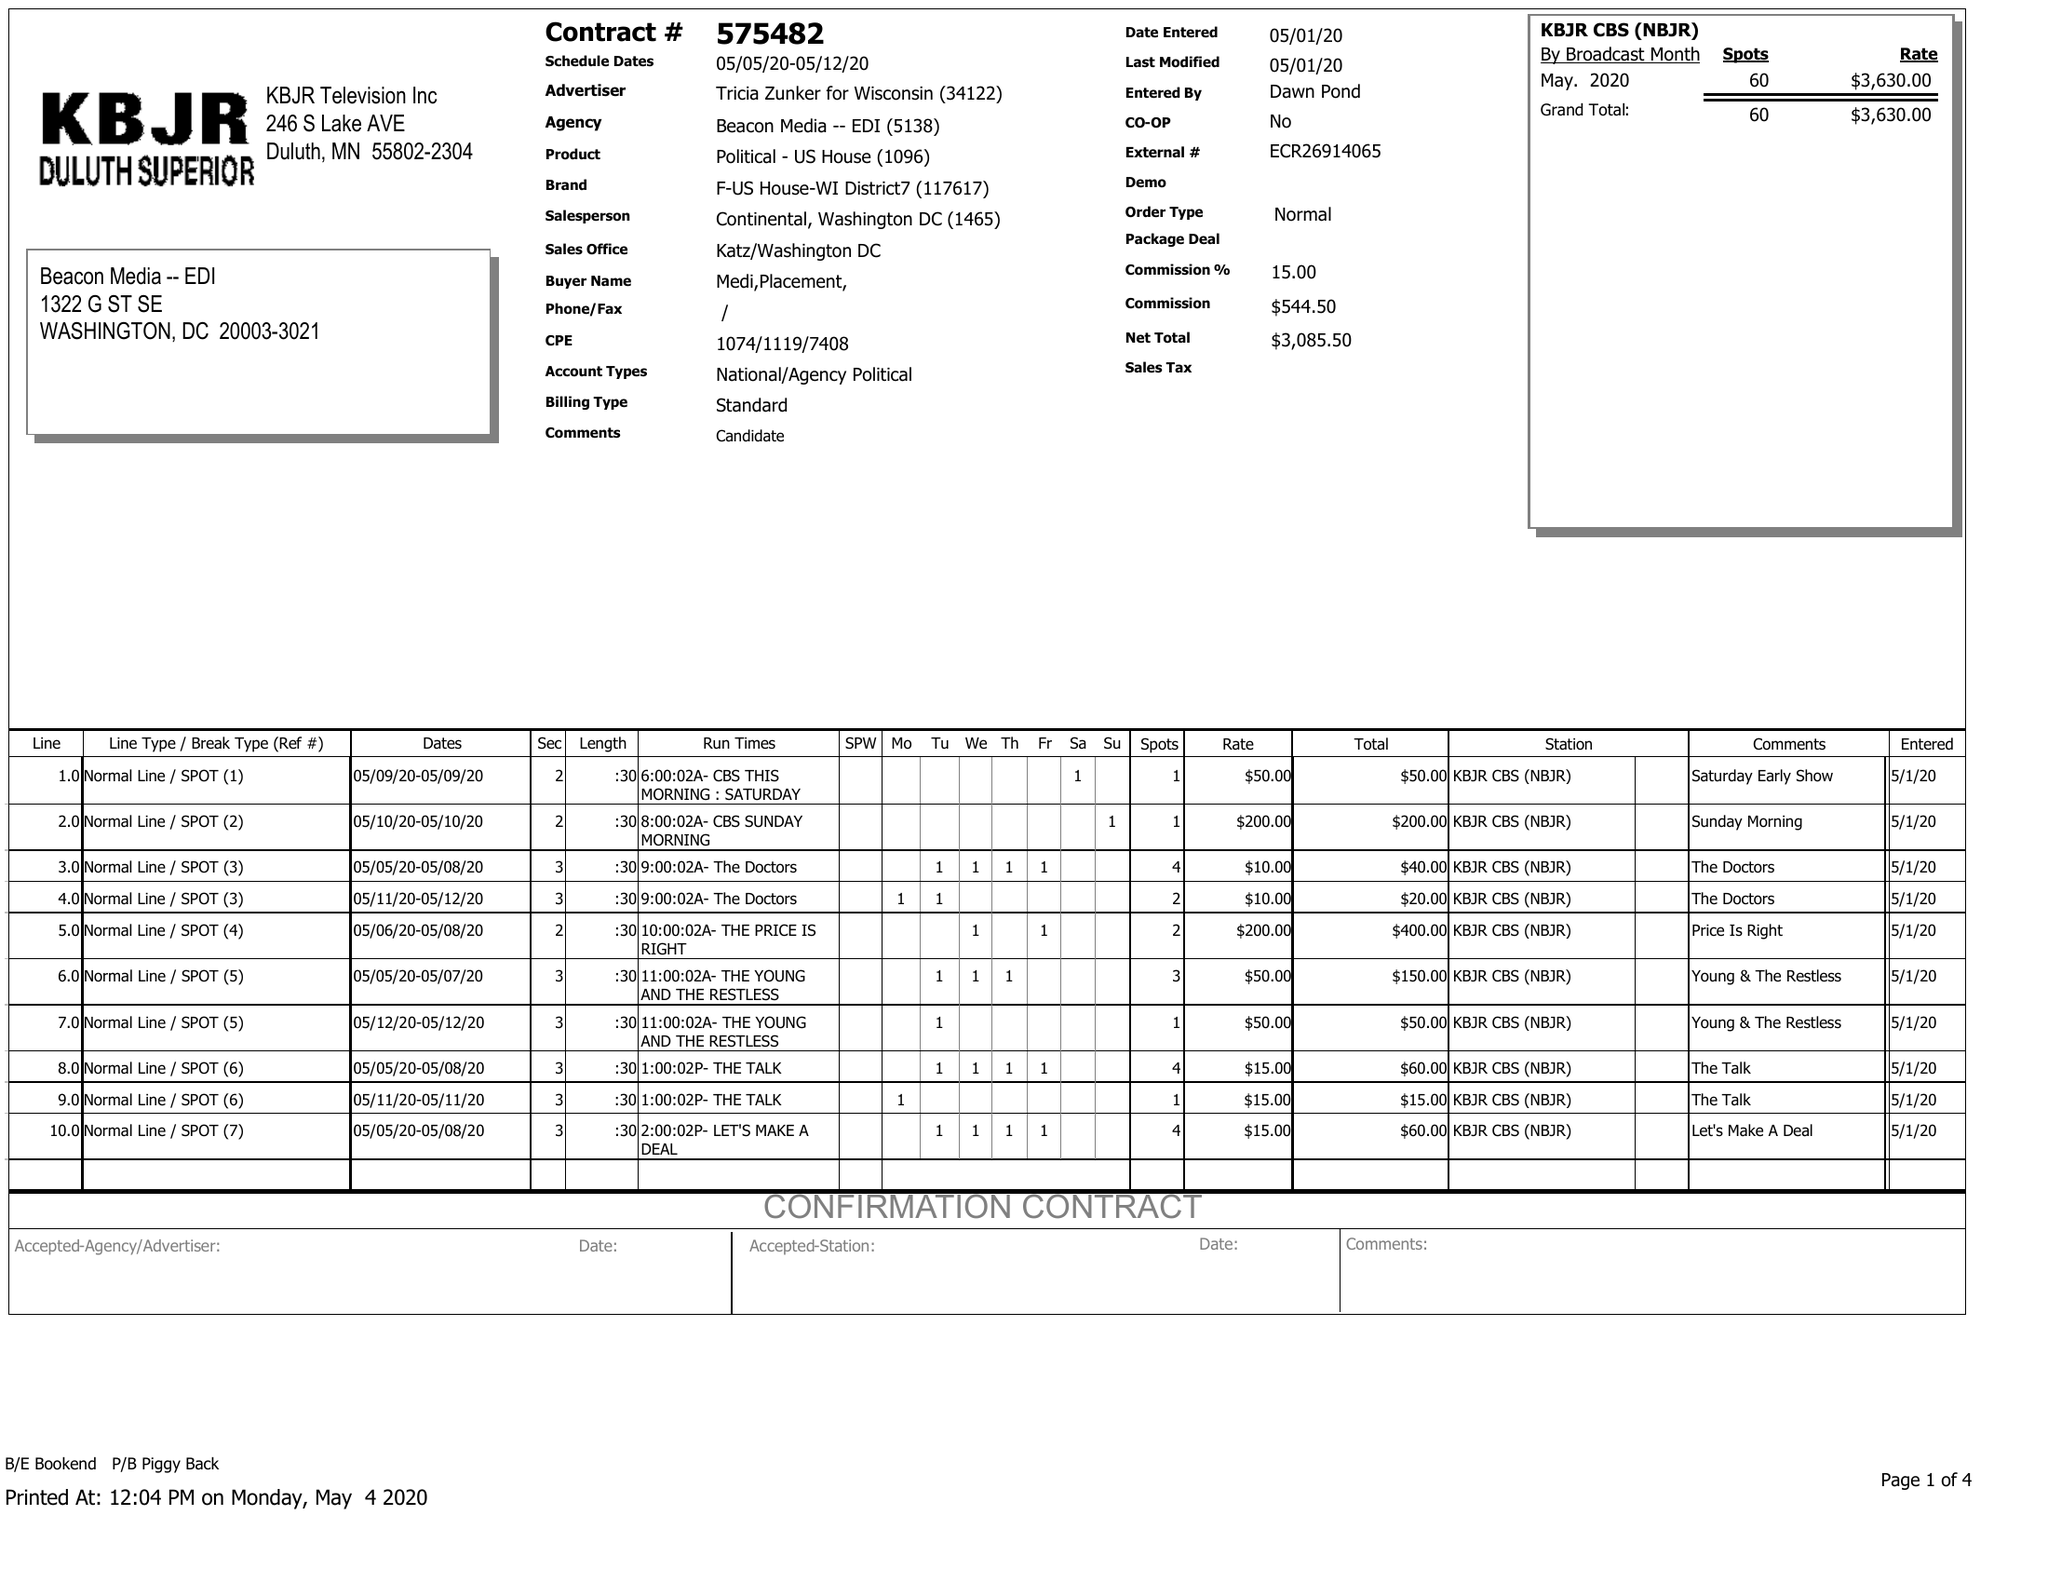What is the value for the flight_to?
Answer the question using a single word or phrase. 05/12/20 